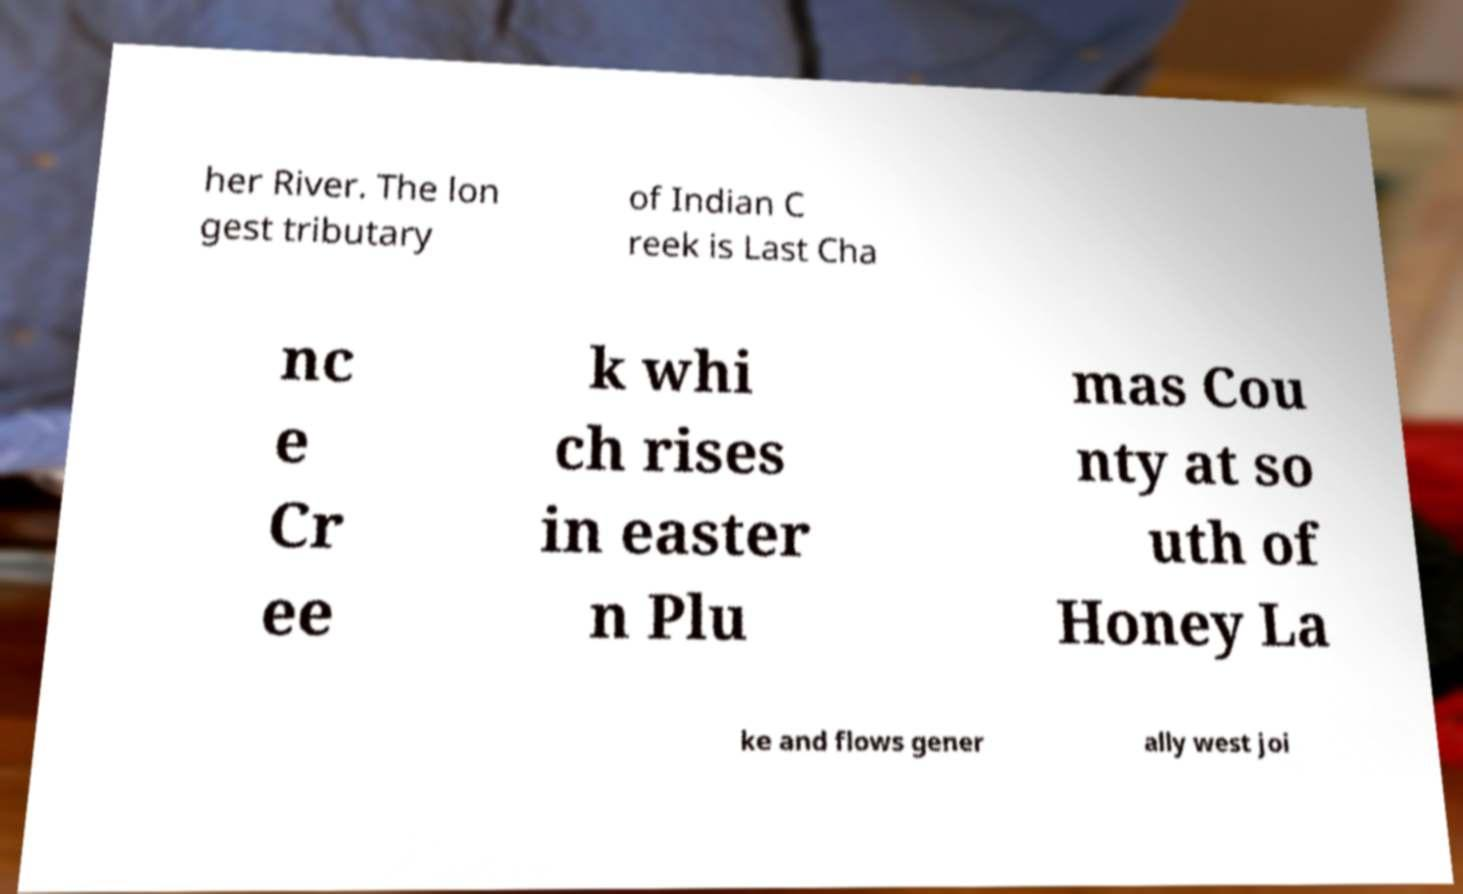Please read and relay the text visible in this image. What does it say? her River. The lon gest tributary of Indian C reek is Last Cha nc e Cr ee k whi ch rises in easter n Plu mas Cou nty at so uth of Honey La ke and flows gener ally west joi 